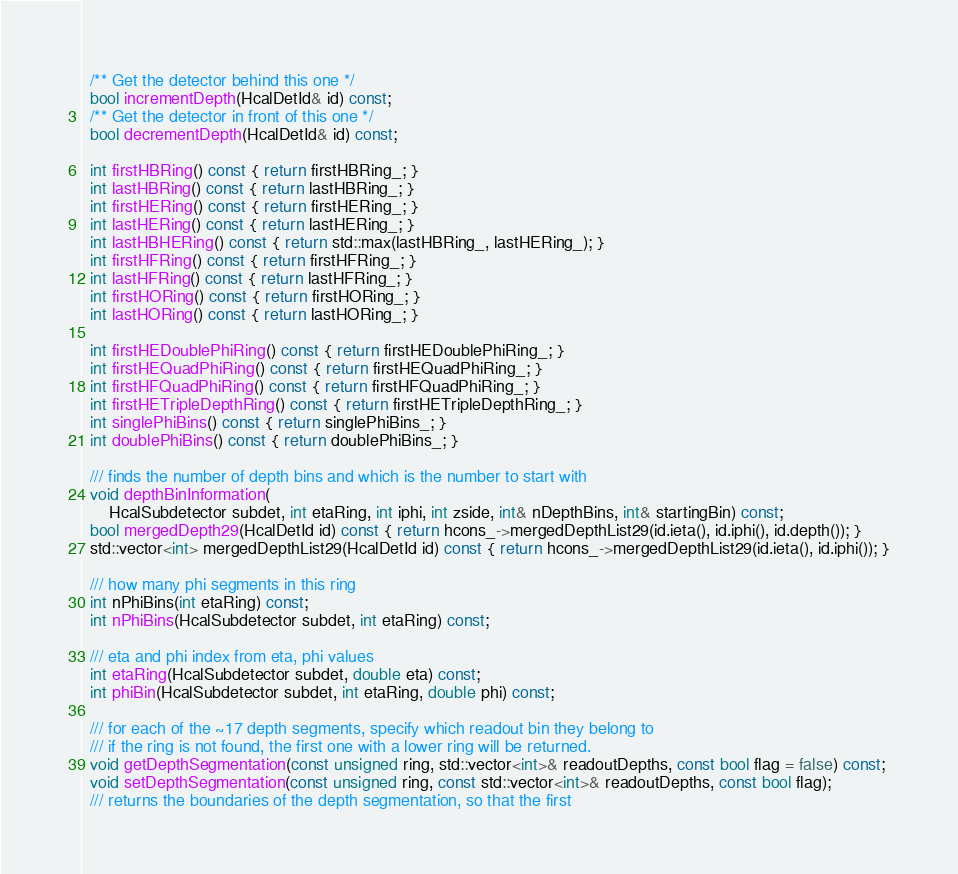<code> <loc_0><loc_0><loc_500><loc_500><_C_>  /** Get the detector behind this one */
  bool incrementDepth(HcalDetId& id) const;
  /** Get the detector in front of this one */
  bool decrementDepth(HcalDetId& id) const;

  int firstHBRing() const { return firstHBRing_; }
  int lastHBRing() const { return lastHBRing_; }
  int firstHERing() const { return firstHERing_; }
  int lastHERing() const { return lastHERing_; }
  int lastHBHERing() const { return std::max(lastHBRing_, lastHERing_); }
  int firstHFRing() const { return firstHFRing_; }
  int lastHFRing() const { return lastHFRing_; }
  int firstHORing() const { return firstHORing_; }
  int lastHORing() const { return lastHORing_; }

  int firstHEDoublePhiRing() const { return firstHEDoublePhiRing_; }
  int firstHEQuadPhiRing() const { return firstHEQuadPhiRing_; }
  int firstHFQuadPhiRing() const { return firstHFQuadPhiRing_; }
  int firstHETripleDepthRing() const { return firstHETripleDepthRing_; }
  int singlePhiBins() const { return singlePhiBins_; }
  int doublePhiBins() const { return doublePhiBins_; }

  /// finds the number of depth bins and which is the number to start with
  void depthBinInformation(
      HcalSubdetector subdet, int etaRing, int iphi, int zside, int& nDepthBins, int& startingBin) const;
  bool mergedDepth29(HcalDetId id) const { return hcons_->mergedDepthList29(id.ieta(), id.iphi(), id.depth()); }
  std::vector<int> mergedDepthList29(HcalDetId id) const { return hcons_->mergedDepthList29(id.ieta(), id.iphi()); }

  /// how many phi segments in this ring
  int nPhiBins(int etaRing) const;
  int nPhiBins(HcalSubdetector subdet, int etaRing) const;

  /// eta and phi index from eta, phi values
  int etaRing(HcalSubdetector subdet, double eta) const;
  int phiBin(HcalSubdetector subdet, int etaRing, double phi) const;

  /// for each of the ~17 depth segments, specify which readout bin they belong to
  /// if the ring is not found, the first one with a lower ring will be returned.
  void getDepthSegmentation(const unsigned ring, std::vector<int>& readoutDepths, const bool flag = false) const;
  void setDepthSegmentation(const unsigned ring, const std::vector<int>& readoutDepths, const bool flag);
  /// returns the boundaries of the depth segmentation, so that the first</code> 